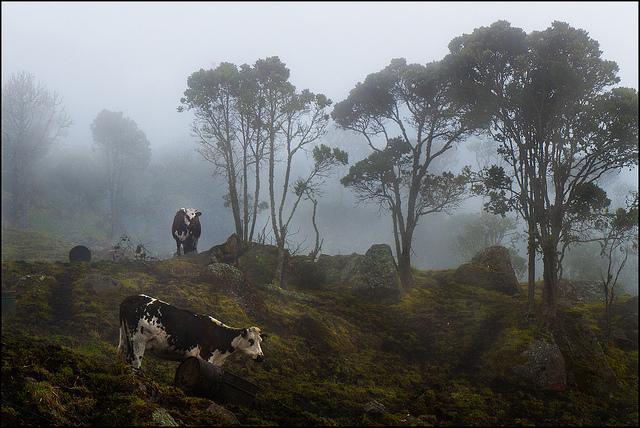How many trains do you see?
Give a very brief answer. 0. How many cows are there?
Give a very brief answer. 1. 